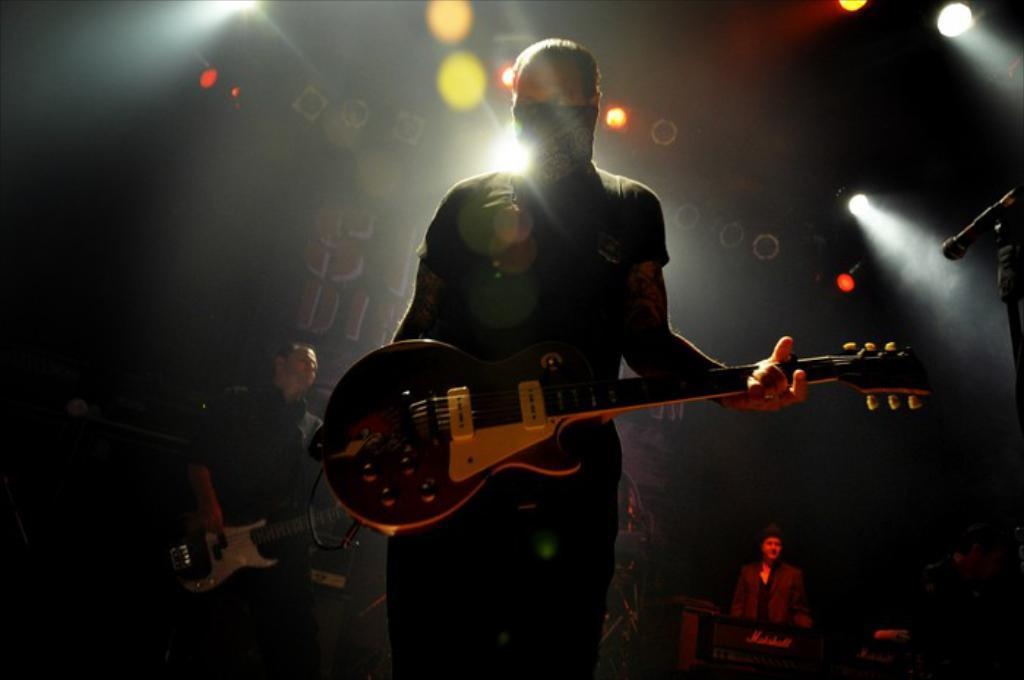How many people are in the image? There are four persons in the image. What are two of the persons holding? Two of the persons are holding guitars. What object is present for amplifying sound? There is a microphone in the image. What can be seen in the background of the image? There are lights visible in the background. How many thumbs can be seen on the guitar players in the image? The number of thumbs cannot be determined from the image, as only the guitars and not the hands holding them are visible. Are there any horses present in the image? No, there are no horses present in the image. 